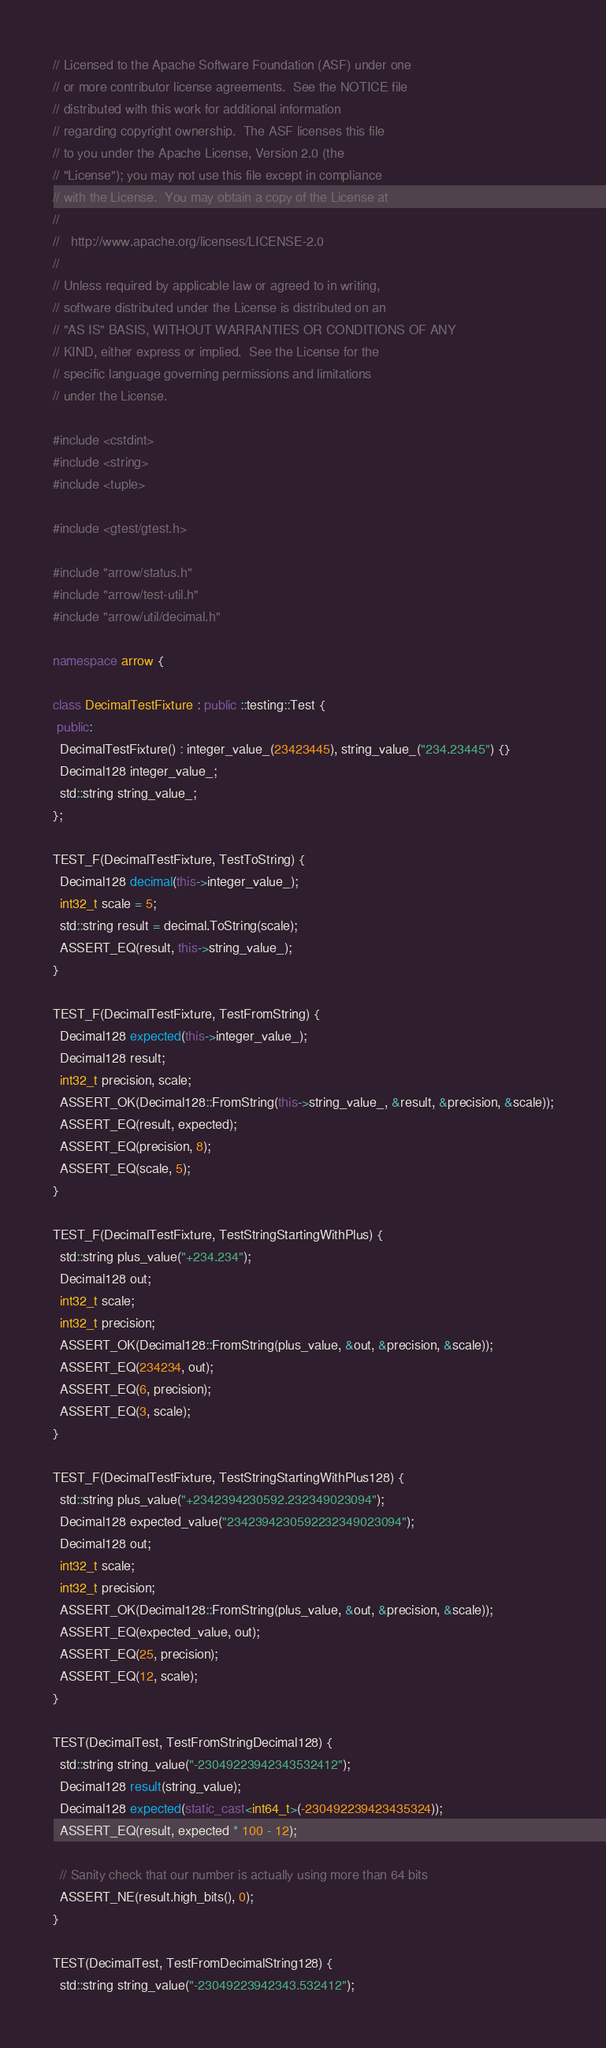<code> <loc_0><loc_0><loc_500><loc_500><_C++_>// Licensed to the Apache Software Foundation (ASF) under one
// or more contributor license agreements.  See the NOTICE file
// distributed with this work for additional information
// regarding copyright ownership.  The ASF licenses this file
// to you under the Apache License, Version 2.0 (the
// "License"); you may not use this file except in compliance
// with the License.  You may obtain a copy of the License at
//
//   http://www.apache.org/licenses/LICENSE-2.0
//
// Unless required by applicable law or agreed to in writing,
// software distributed under the License is distributed on an
// "AS IS" BASIS, WITHOUT WARRANTIES OR CONDITIONS OF ANY
// KIND, either express or implied.  See the License for the
// specific language governing permissions and limitations
// under the License.

#include <cstdint>
#include <string>
#include <tuple>

#include <gtest/gtest.h>

#include "arrow/status.h"
#include "arrow/test-util.h"
#include "arrow/util/decimal.h"

namespace arrow {

class DecimalTestFixture : public ::testing::Test {
 public:
  DecimalTestFixture() : integer_value_(23423445), string_value_("234.23445") {}
  Decimal128 integer_value_;
  std::string string_value_;
};

TEST_F(DecimalTestFixture, TestToString) {
  Decimal128 decimal(this->integer_value_);
  int32_t scale = 5;
  std::string result = decimal.ToString(scale);
  ASSERT_EQ(result, this->string_value_);
}

TEST_F(DecimalTestFixture, TestFromString) {
  Decimal128 expected(this->integer_value_);
  Decimal128 result;
  int32_t precision, scale;
  ASSERT_OK(Decimal128::FromString(this->string_value_, &result, &precision, &scale));
  ASSERT_EQ(result, expected);
  ASSERT_EQ(precision, 8);
  ASSERT_EQ(scale, 5);
}

TEST_F(DecimalTestFixture, TestStringStartingWithPlus) {
  std::string plus_value("+234.234");
  Decimal128 out;
  int32_t scale;
  int32_t precision;
  ASSERT_OK(Decimal128::FromString(plus_value, &out, &precision, &scale));
  ASSERT_EQ(234234, out);
  ASSERT_EQ(6, precision);
  ASSERT_EQ(3, scale);
}

TEST_F(DecimalTestFixture, TestStringStartingWithPlus128) {
  std::string plus_value("+2342394230592.232349023094");
  Decimal128 expected_value("2342394230592232349023094");
  Decimal128 out;
  int32_t scale;
  int32_t precision;
  ASSERT_OK(Decimal128::FromString(plus_value, &out, &precision, &scale));
  ASSERT_EQ(expected_value, out);
  ASSERT_EQ(25, precision);
  ASSERT_EQ(12, scale);
}

TEST(DecimalTest, TestFromStringDecimal128) {
  std::string string_value("-23049223942343532412");
  Decimal128 result(string_value);
  Decimal128 expected(static_cast<int64_t>(-230492239423435324));
  ASSERT_EQ(result, expected * 100 - 12);

  // Sanity check that our number is actually using more than 64 bits
  ASSERT_NE(result.high_bits(), 0);
}

TEST(DecimalTest, TestFromDecimalString128) {
  std::string string_value("-23049223942343.532412");</code> 